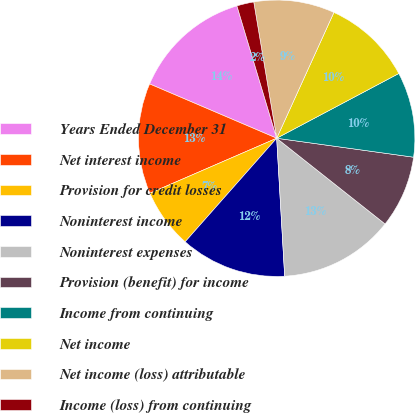Convert chart. <chart><loc_0><loc_0><loc_500><loc_500><pie_chart><fcel>Years Ended December 31<fcel>Net interest income<fcel>Provision for credit losses<fcel>Noninterest income<fcel>Noninterest expenses<fcel>Provision (benefit) for income<fcel>Income from continuing<fcel>Net income<fcel>Net income (loss) attributable<fcel>Income (loss) from continuing<nl><fcel>13.93%<fcel>12.94%<fcel>6.97%<fcel>12.44%<fcel>13.43%<fcel>8.46%<fcel>9.95%<fcel>10.45%<fcel>9.45%<fcel>1.99%<nl></chart> 